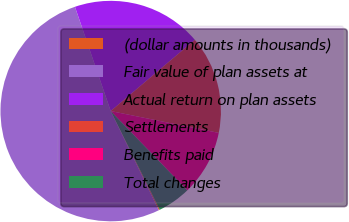Convert chart. <chart><loc_0><loc_0><loc_500><loc_500><pie_chart><fcel>(dollar amounts in thousands)<fcel>Fair value of plan assets at<fcel>Actual return on plan assets<fcel>Settlements<fcel>Benefits paid<fcel>Total changes<nl><fcel>0.15%<fcel>51.93%<fcel>19.08%<fcel>14.35%<fcel>9.61%<fcel>4.88%<nl></chart> 